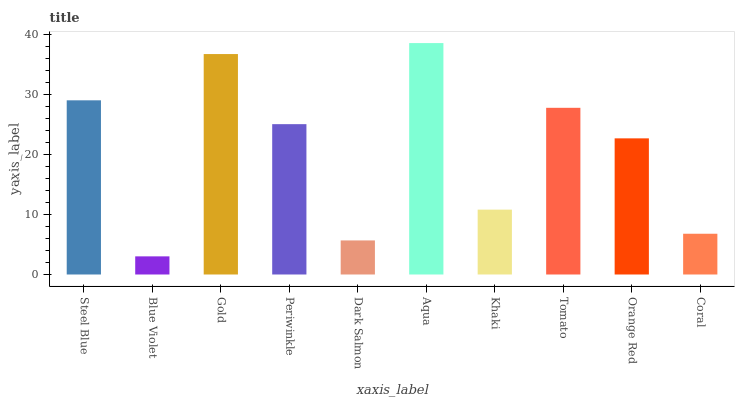Is Gold the minimum?
Answer yes or no. No. Is Gold the maximum?
Answer yes or no. No. Is Gold greater than Blue Violet?
Answer yes or no. Yes. Is Blue Violet less than Gold?
Answer yes or no. Yes. Is Blue Violet greater than Gold?
Answer yes or no. No. Is Gold less than Blue Violet?
Answer yes or no. No. Is Periwinkle the high median?
Answer yes or no. Yes. Is Orange Red the low median?
Answer yes or no. Yes. Is Gold the high median?
Answer yes or no. No. Is Gold the low median?
Answer yes or no. No. 